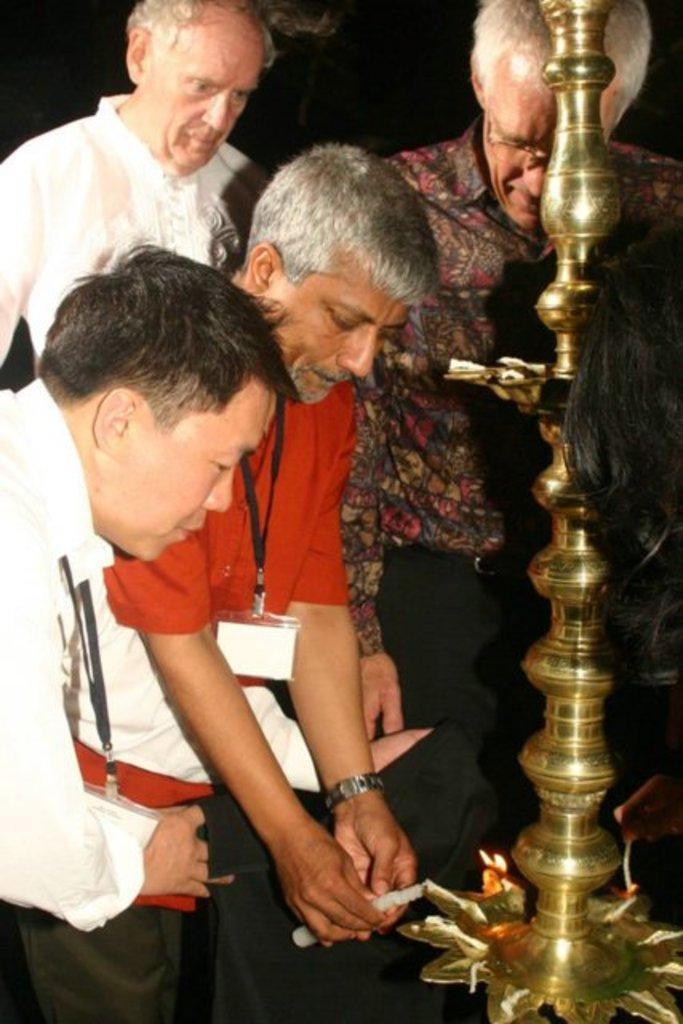Can you describe this image briefly? In this image we can see few people standing near a stand and a person is holding a candle. 